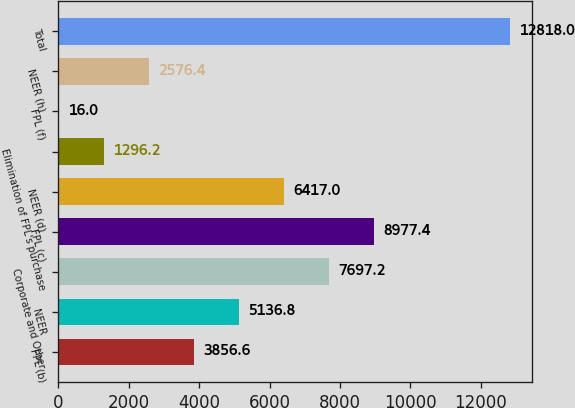Convert chart. <chart><loc_0><loc_0><loc_500><loc_500><bar_chart><fcel>FPL (b)<fcel>NEER<fcel>Corporate and Other<fcel>FPL (c)<fcel>NEER (d)<fcel>Elimination of FPL's purchase<fcel>FPL (f)<fcel>NEER (h)<fcel>Total<nl><fcel>3856.6<fcel>5136.8<fcel>7697.2<fcel>8977.4<fcel>6417<fcel>1296.2<fcel>16<fcel>2576.4<fcel>12818<nl></chart> 